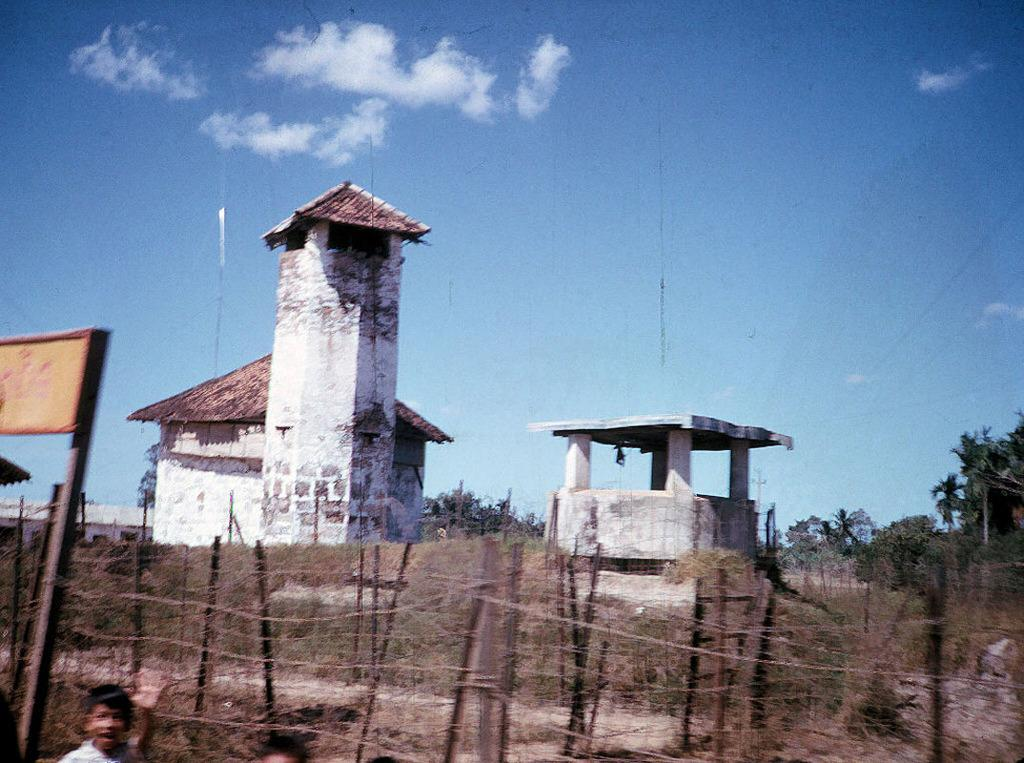What type of structures can be seen in the image? There are pillars, walls, and sheds in the image. What type of enclosure is present in the image? There is fencing in the image. What type of signage is present in the image? There is a sign board in the image. What type of vegetation is present in the image? There are trees and plants in the image. Who or what is present at the bottom of the image? There are kids at the bottom of the image. What is visible at the top of the image? The sky is visible at the top of the image. What type of flesh can be seen hanging from the trees in the image? There is no flesh present in the image; it features trees and plants. Can you tell me how many dinosaurs are visible in the image? There are no dinosaurs present in the image. 